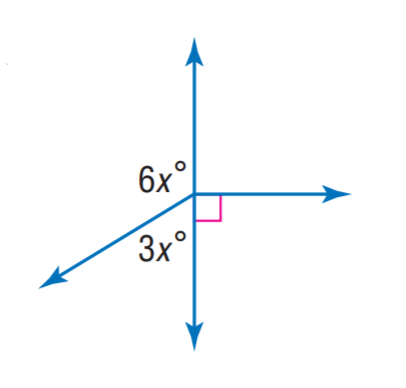Answer the mathemtical geometry problem and directly provide the correct option letter.
Question: Find x.
Choices: A: 10 B: 20 C: 30 D: 40 B 